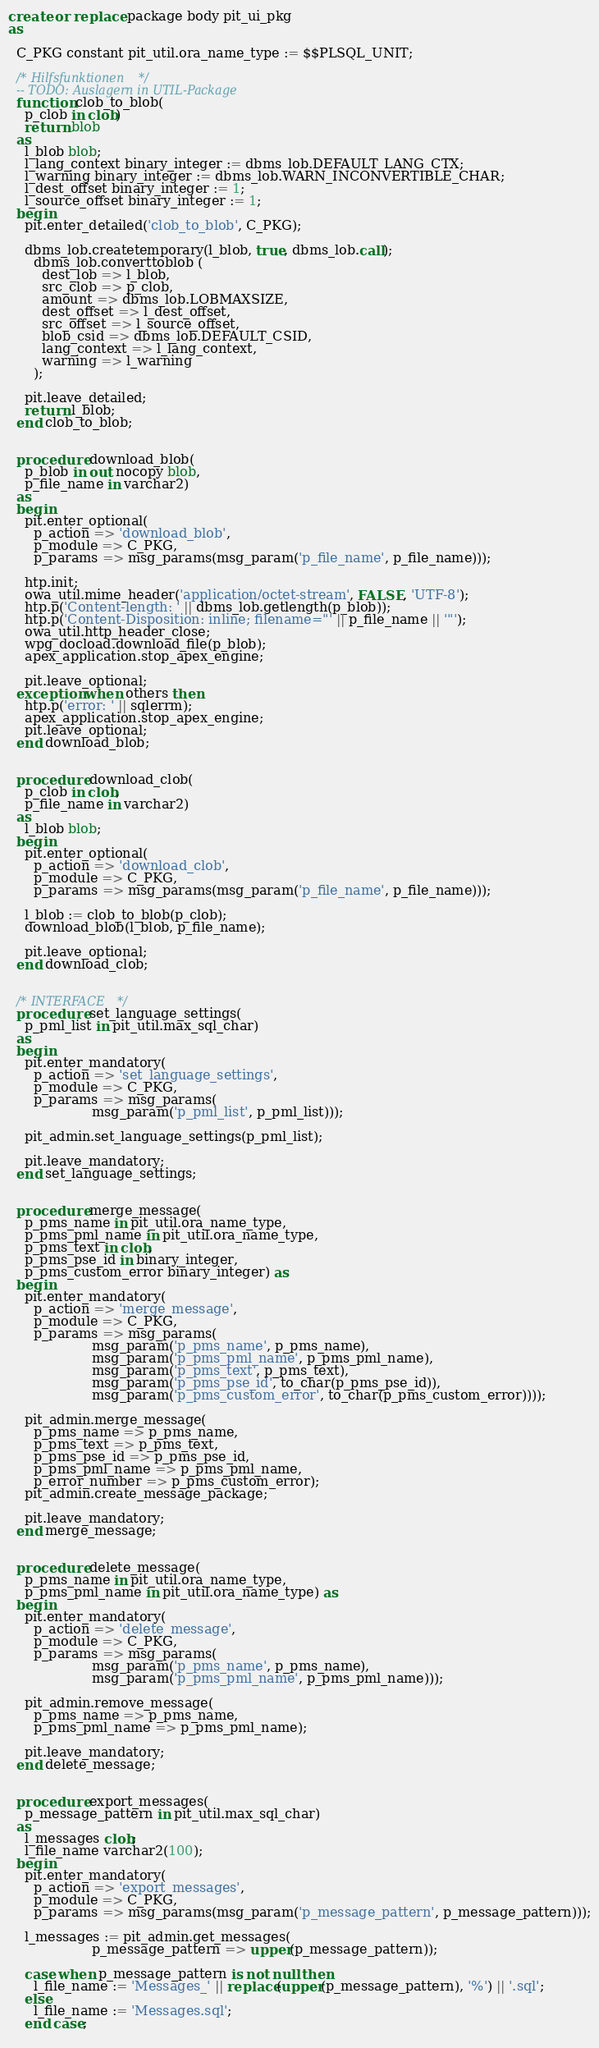<code> <loc_0><loc_0><loc_500><loc_500><_SQL_>create or replace package body pit_ui_pkg 
as

  C_PKG constant pit_util.ora_name_type := $$PLSQL_UNIT;
  
  /* Hilfsfunktionen */
  -- TODO: Auslagern in UTIL-Package
  function clob_to_blob(
    p_clob in clob)
    return blob
  as
    l_blob blob;
    l_lang_context binary_integer := dbms_lob.DEFAULT_LANG_CTX;
    l_warning binary_integer := dbms_lob.WARN_INCONVERTIBLE_CHAR;
    l_dest_offset binary_integer := 1;
    l_source_offset binary_integer := 1;
  begin
    pit.enter_detailed('clob_to_blob', C_PKG);
    
    dbms_lob.createtemporary(l_blob, true, dbms_lob.call);
      dbms_lob.converttoblob (
        dest_lob => l_blob,
        src_clob => p_clob,
        amount => dbms_lob.LOBMAXSIZE,
        dest_offset => l_dest_offset,
        src_offset => l_source_offset,
        blob_csid => dbms_lob.DEFAULT_CSID,
        lang_context => l_lang_context,
        warning => l_warning
      );
      
    pit.leave_detailed;
    return l_blob;
  end clob_to_blob;
  

  procedure download_blob(
    p_blob in out nocopy blob,
    p_file_name in varchar2)
  as
  begin
    pit.enter_optional(
      p_action => 'download_blob', 
      p_module => C_PKG,
      p_params => msg_params(msg_param('p_file_name', p_file_name)));
    
    htp.init;
    owa_util.mime_header('application/octet-stream', FALSE, 'UTF-8');
    htp.p('Content-length: ' || dbms_lob.getlength(p_blob));
    htp.p('Content-Disposition: inline; filename="' || p_file_name || '"');
    owa_util.http_header_close;
    wpg_docload.download_file(p_blob);
    apex_application.stop_apex_engine;

    pit.leave_optional;
  exception when others then
    htp.p('error: ' || sqlerrm);
    apex_application.stop_apex_engine;
    pit.leave_optional;
  end download_blob;


  procedure download_clob(
    p_clob in clob,
    p_file_name in varchar2)
  as
    l_blob blob;
  begin
    pit.enter_optional(
      p_action => 'download_clob', 
      p_module => C_PKG,
      p_params => msg_params(msg_param('p_file_name', p_file_name)));
    
    l_blob := clob_to_blob(p_clob);
    download_blob(l_blob, p_file_name);
    
    pit.leave_optional;
  end download_clob;
  
  
  /* INTERFACE */
  procedure set_language_settings(
    p_pml_list in pit_util.max_sql_char)
  as
  begin
    pit.enter_mandatory(
      p_action => 'set_language_settings',
      p_module => C_PKG,
      p_params => msg_params(
                    msg_param('p_pml_list', p_pml_list)));
    
    pit_admin.set_language_settings(p_pml_list);
    
    pit.leave_mandatory;
  end set_language_settings;
  

  procedure merge_message(
    p_pms_name in pit_util.ora_name_type,
    p_pms_pml_name in pit_util.ora_name_type,
    p_pms_text in clob,
    p_pms_pse_id in binary_integer,
    p_pms_custom_error binary_integer) as
  begin
    pit.enter_mandatory(
      p_action => 'merge_message',
      p_module => C_PKG,
      p_params => msg_params(
                    msg_param('p_pms_name', p_pms_name),
                    msg_param('p_pms_pml_name', p_pms_pml_name),
                    msg_param('p_pms_text', p_pms_text),
                    msg_param('p_pms_pse_id', to_char(p_pms_pse_id)),
                    msg_param('p_pms_custom_error', to_char(p_pms_custom_error))));
                    
    pit_admin.merge_message(
      p_pms_name => p_pms_name,
      p_pms_text => p_pms_text,
      p_pms_pse_id => p_pms_pse_id,
      p_pms_pml_name => p_pms_pml_name,
      p_error_number => p_pms_custom_error);
    pit_admin.create_message_package;
    
    pit.leave_mandatory;
  end merge_message;
  

  procedure delete_message(
    p_pms_name in pit_util.ora_name_type,
    p_pms_pml_name in pit_util.ora_name_type) as
  begin
    pit.enter_mandatory(
      p_action => 'delete_message',
      p_module => C_PKG,
      p_params => msg_params(
                    msg_param('p_pms_name', p_pms_name),
                    msg_param('p_pms_pml_name', p_pms_pml_name)));
                    
    pit_admin.remove_message(
      p_pms_name => p_pms_name,
      p_pms_pml_name => p_pms_pml_name);
    
    pit.leave_mandatory;
  end delete_message;
  
    
  procedure export_messages(
    p_message_pattern in pit_util.max_sql_char)
  as
    l_messages clob;
    l_file_name varchar2(100);
  begin
    pit.enter_mandatory(
      p_action => 'export_messages',
      p_module => C_PKG,
      p_params => msg_params(msg_param('p_message_pattern', p_message_pattern)));
      
    l_messages := pit_admin.get_messages(
                    p_message_pattern => upper(p_message_pattern));
    
    case when p_message_pattern is not null then
      l_file_name := 'Messages_' || replace(upper(p_message_pattern), '%') || '.sql';
    else
      l_file_name := 'Messages.sql';
    end case;
    </code> 